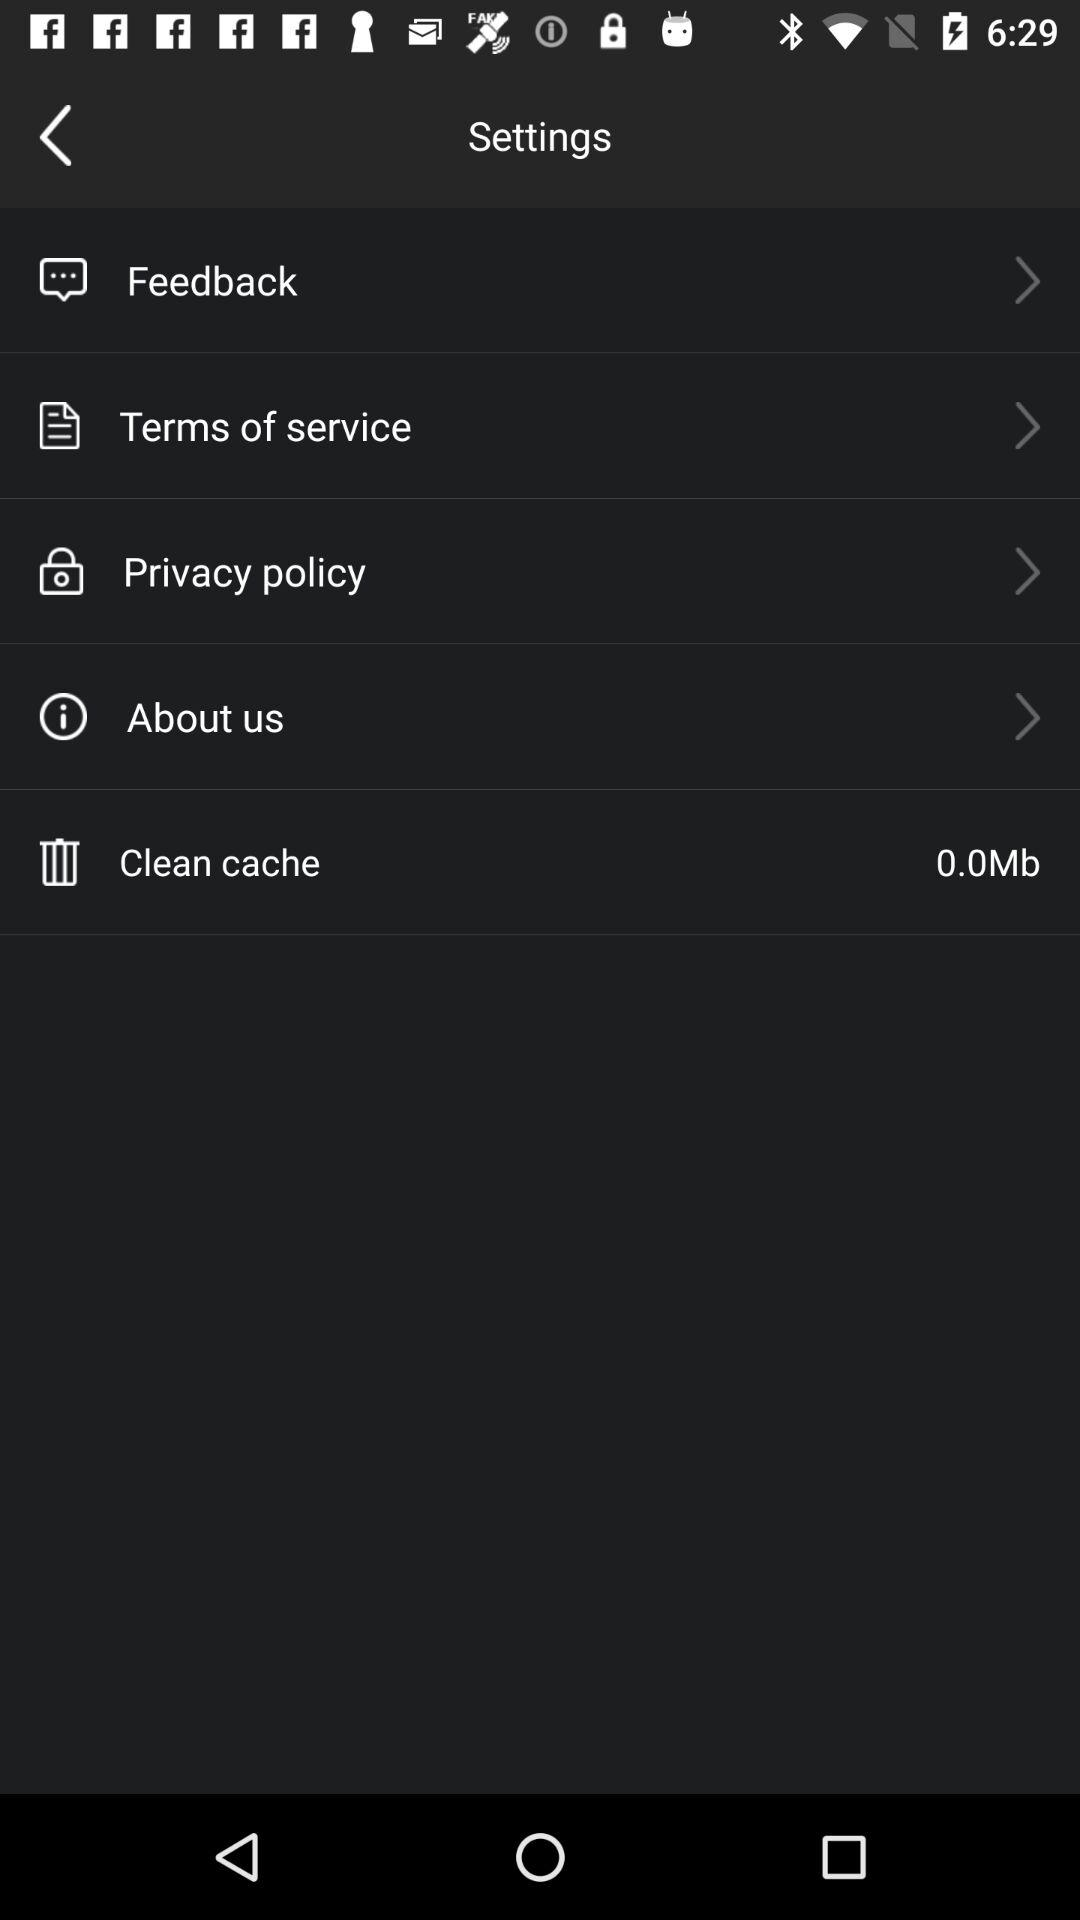How much space does the cache take up?
Answer the question using a single word or phrase. 0.0Mb 